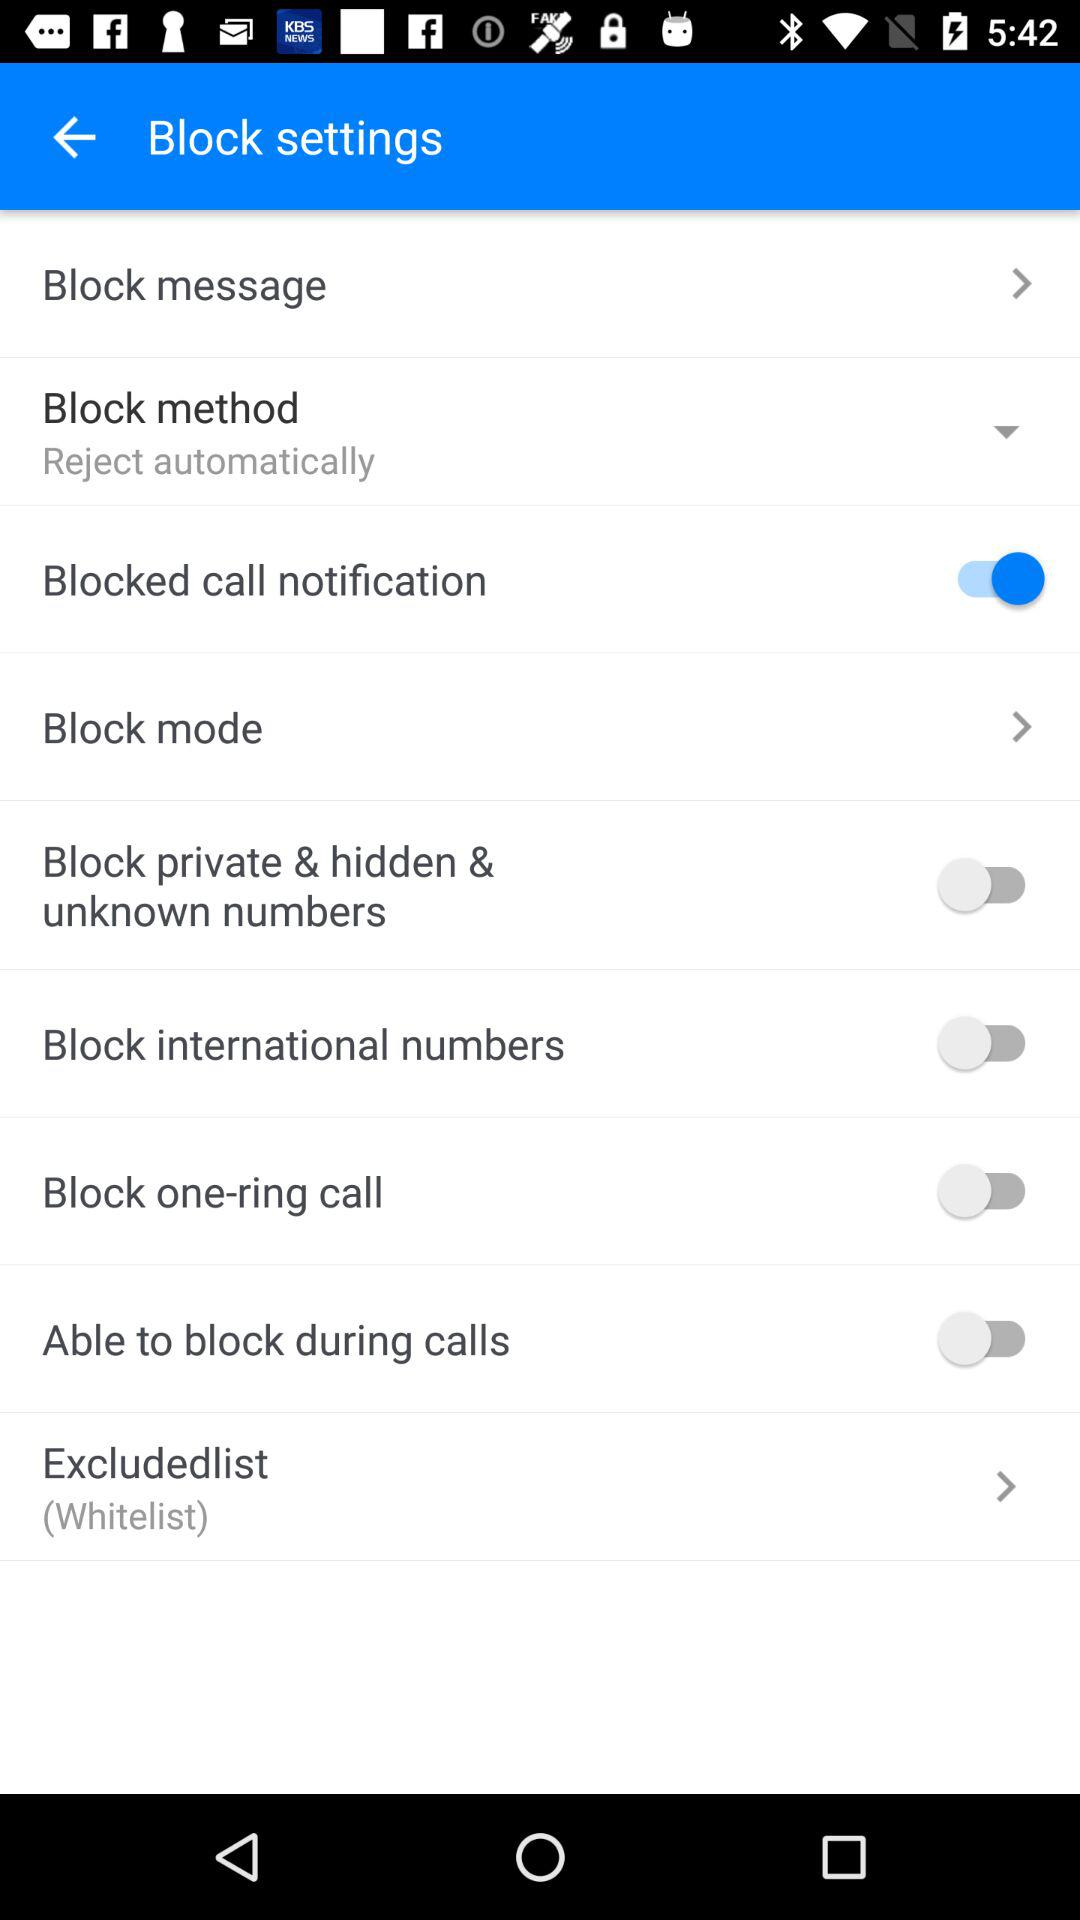What is the setting for "Block method"? The setting for "Block method" is "Reject automatically". 